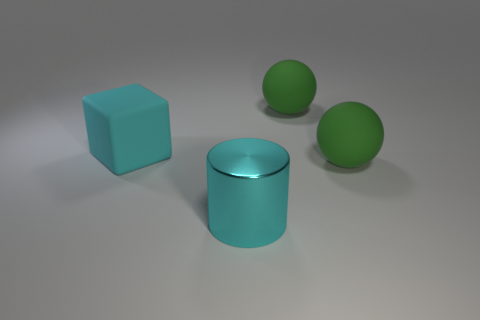Add 4 green rubber spheres. How many objects exist? 8 Subtract all blocks. How many objects are left? 3 Subtract all large matte objects. Subtract all cyan blocks. How many objects are left? 0 Add 2 large matte spheres. How many large matte spheres are left? 4 Add 3 large cyan shiny things. How many large cyan shiny things exist? 4 Subtract 0 gray cubes. How many objects are left? 4 